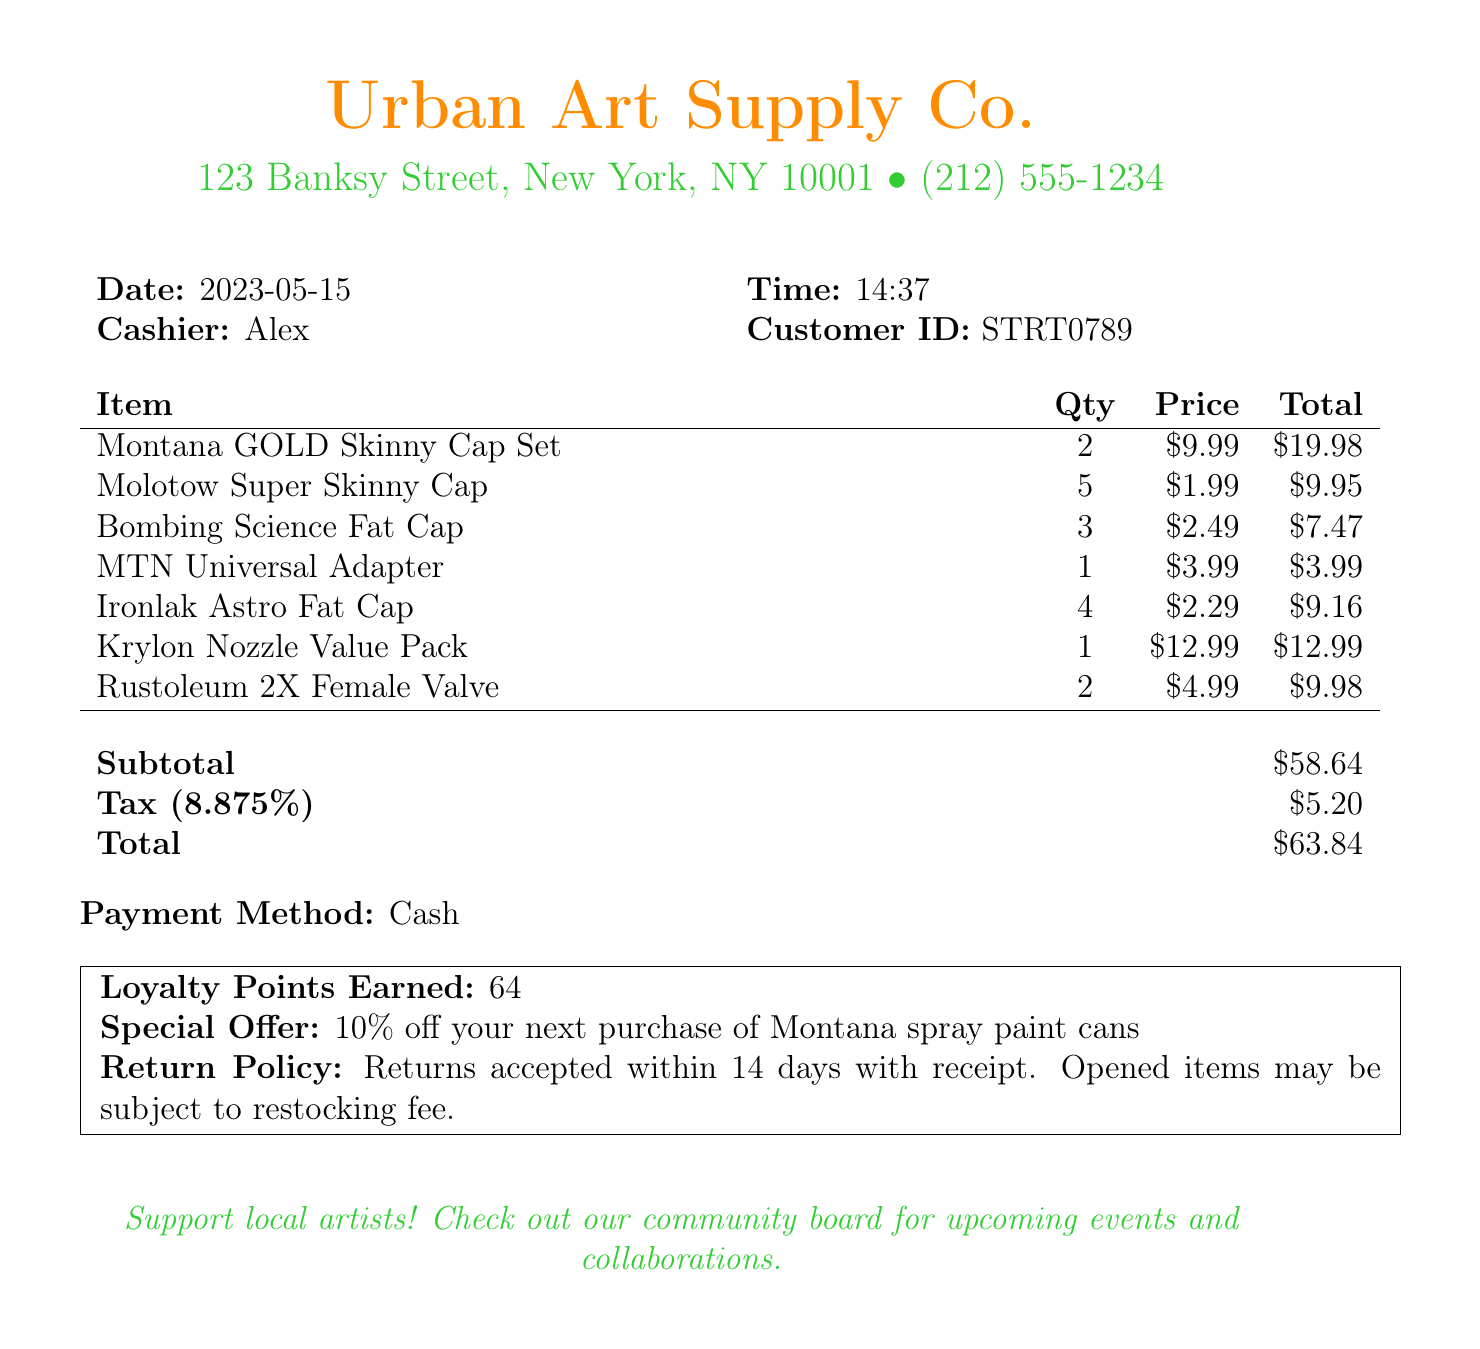What is the name of the store? The name of the store is prominently displayed at the top of the document.
Answer: Urban Art Supply Co What items did I purchase? The document lists all items bought in the transaction.
Answer: Montana GOLD Skinny Cap Set, Molotow Super Skinny Cap, Bombing Science Fat Cap, MTN Universal Adapter, Ironlak Astro Fat Cap, Krylon Nozzle Value Pack, Rustoleum 2X Female Valve How many Molotow Super Skinny Caps did I buy? The quantity is indicated next to each item description in the document.
Answer: 5 What is the total amount spent? The total amount is calculated and clearly stated in the document.
Answer: $63.84 What was the tax amount? The document specifies the tax amount separately from the subtotal.
Answer: $5.20 What loyalty points did I earn? The number of loyalty points earned is noted in a highlighted box on the receipt.
Answer: 64 What is the return policy? The return policy is outlined in a specified section of the receipt.
Answer: Returns accepted within 14 days with receipt What payment method was used? The payment method is stated clearly in the document.
Answer: Cash What special offer is mentioned? The special offer is noted in the highlighted box on the receipt.
Answer: 10% off your next purchase of Montana spray paint cans 